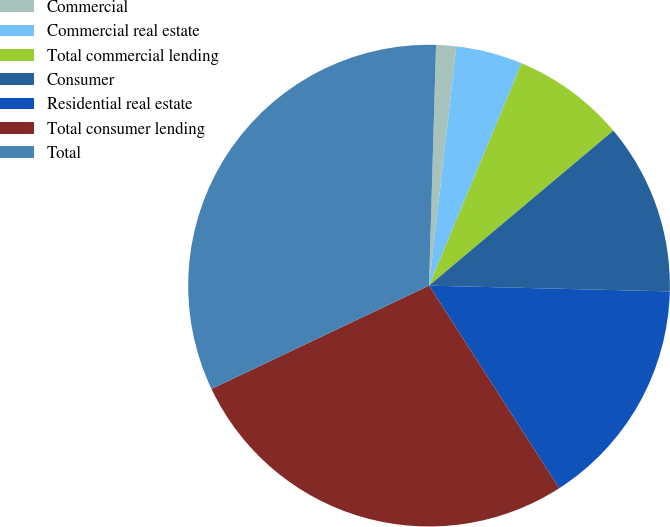<chart> <loc_0><loc_0><loc_500><loc_500><pie_chart><fcel>Commercial<fcel>Commercial real estate<fcel>Total commercial lending<fcel>Consumer<fcel>Residential real estate<fcel>Total consumer lending<fcel>Total<nl><fcel>1.35%<fcel>4.47%<fcel>7.59%<fcel>11.51%<fcel>15.53%<fcel>27.04%<fcel>32.52%<nl></chart> 